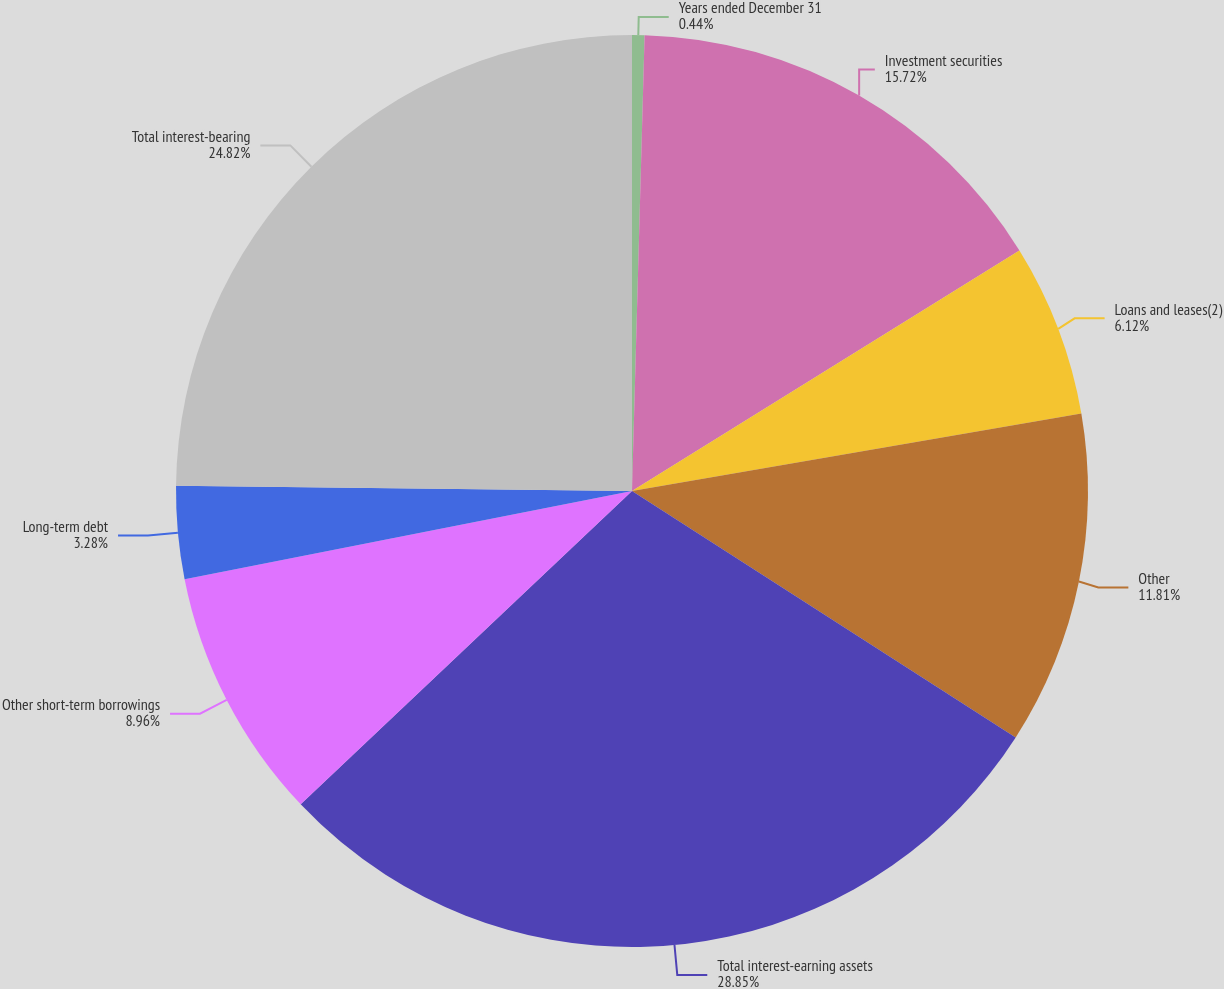Convert chart to OTSL. <chart><loc_0><loc_0><loc_500><loc_500><pie_chart><fcel>Years ended December 31<fcel>Investment securities<fcel>Loans and leases(2)<fcel>Other<fcel>Total interest-earning assets<fcel>Other short-term borrowings<fcel>Long-term debt<fcel>Total interest-bearing<nl><fcel>0.44%<fcel>15.72%<fcel>6.12%<fcel>11.81%<fcel>28.86%<fcel>8.96%<fcel>3.28%<fcel>24.82%<nl></chart> 